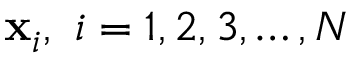Convert formula to latex. <formula><loc_0><loc_0><loc_500><loc_500>x _ { i } , \ i = 1 , 2 , 3 , \dots c , N</formula> 